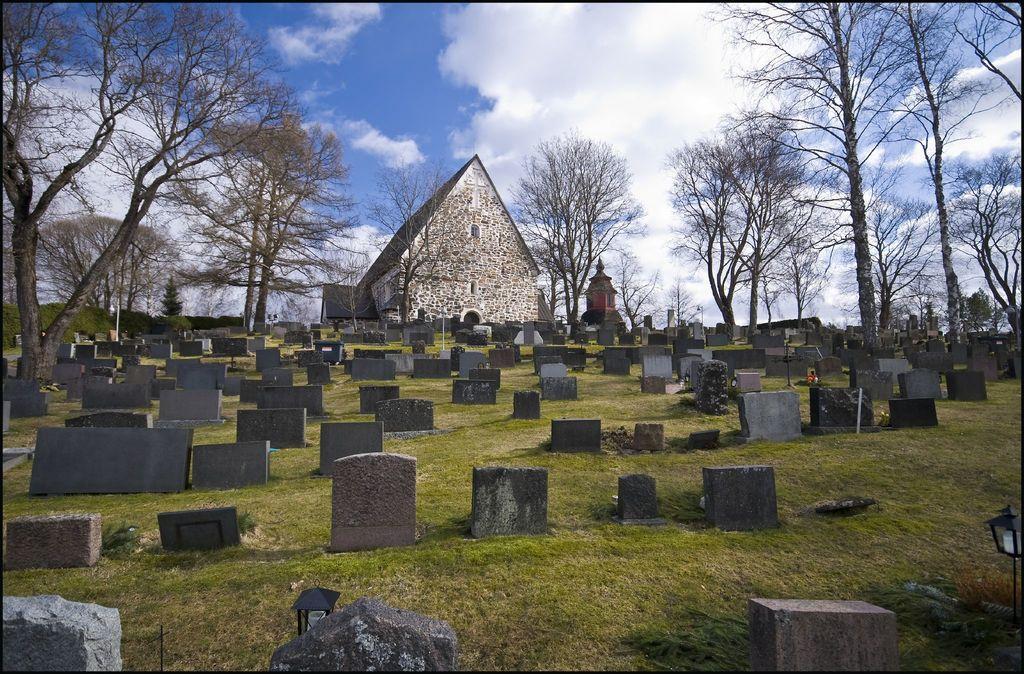Please provide a concise description of this image. This is a picture taken in the cemetery. In the foreground there are gravestones. In the center of the picture there are trees and church. Sky is cloudy. 